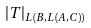<formula> <loc_0><loc_0><loc_500><loc_500>| T | _ { L ( B , L ( A , C ) ) }</formula> 